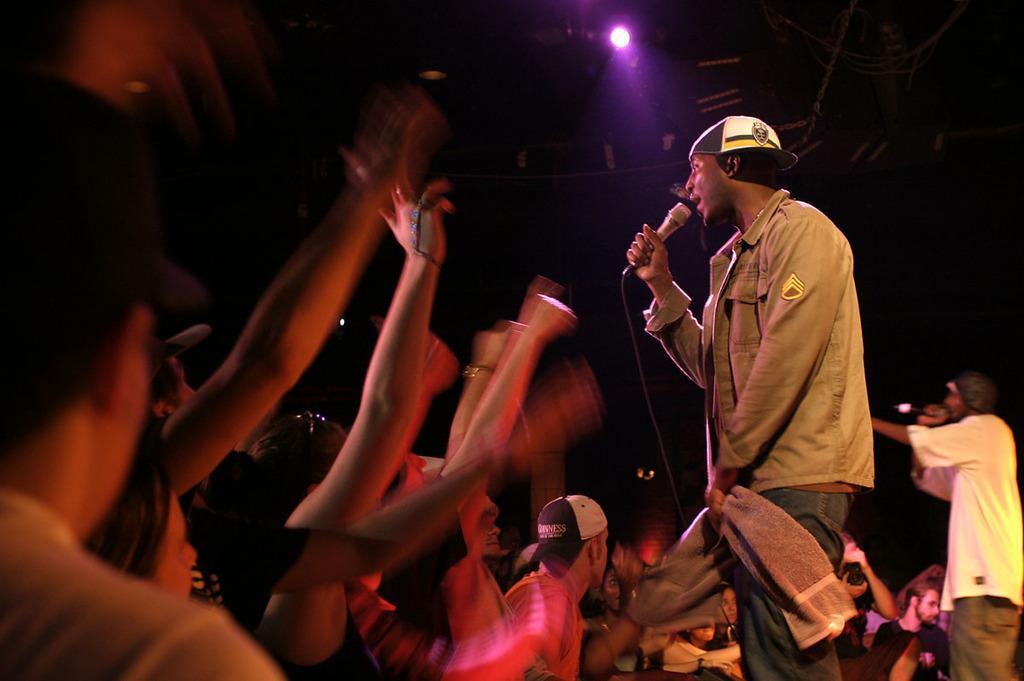Could you give a brief overview of what you see in this image? On the left side of the image we can see crowd raising their hands, but it is in a blur. On the right side of the image we can see two persons are singing the song. 